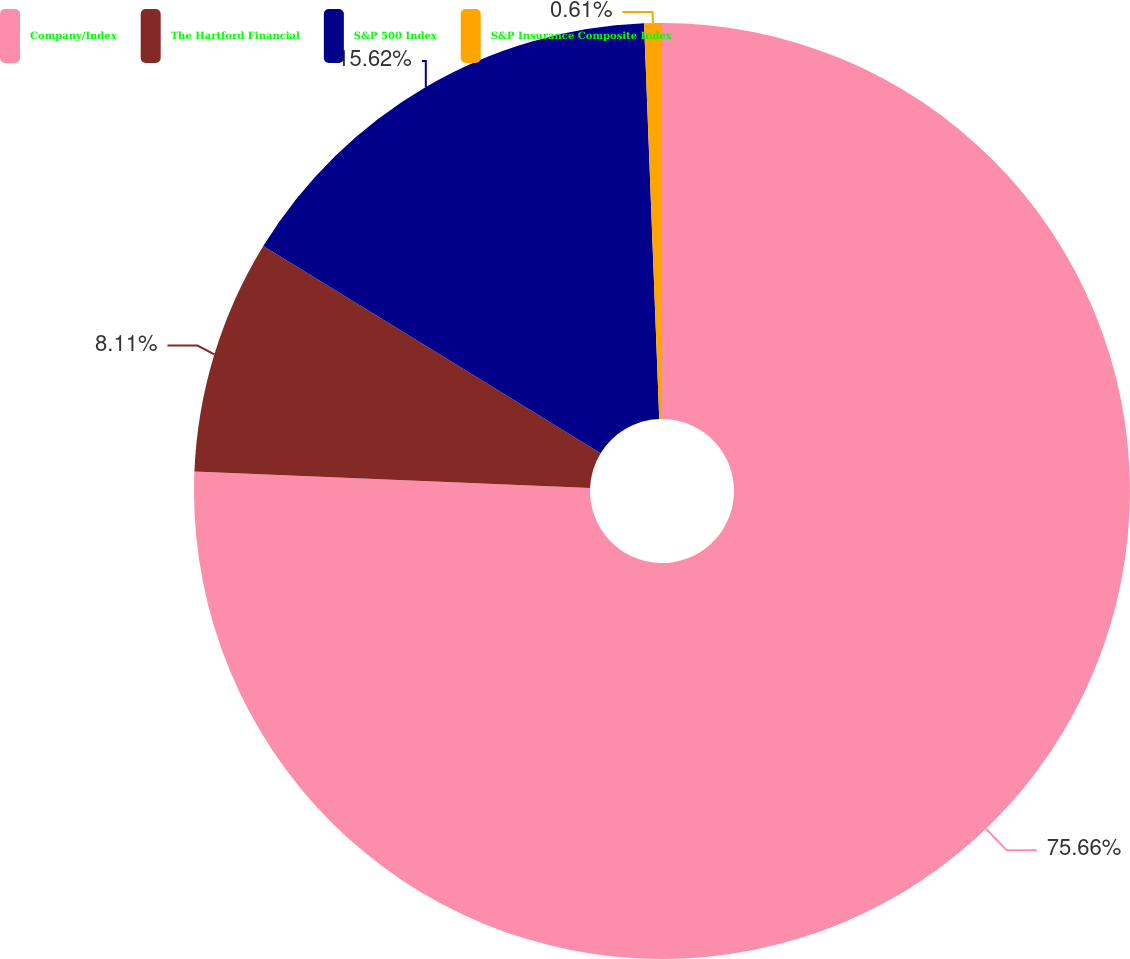Convert chart. <chart><loc_0><loc_0><loc_500><loc_500><pie_chart><fcel>Company/Index<fcel>The Hartford Financial<fcel>S&P 500 Index<fcel>S&P Insurance Composite Index<nl><fcel>75.66%<fcel>8.11%<fcel>15.62%<fcel>0.61%<nl></chart> 